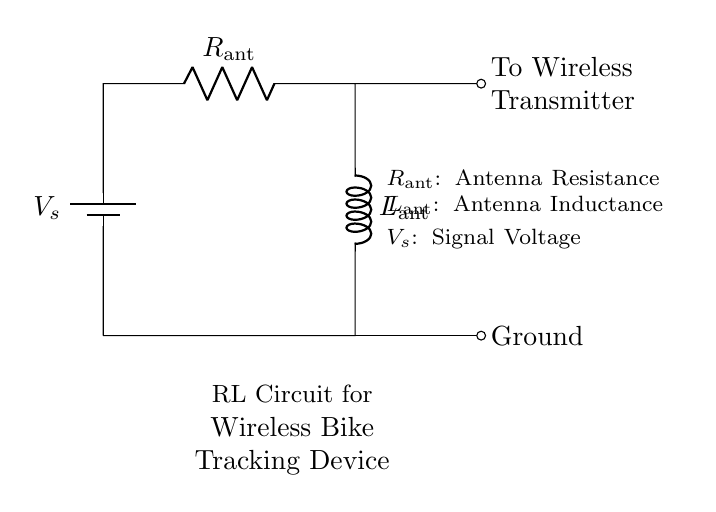What is the signal voltage in the circuit? The signal voltage is indicated by \( V_{s} \) in the battery symbol. It represents the source voltage for the circuit.
Answer: \( V_{s} \) What components are present in the circuit? The circuit consists of a battery, a resistor, and an inductor, which are labeled as \( V_{s} \), \( R_{\text{ant}} \), and \( L_{\text{ant}} \) respectively.
Answer: Battery, Resistor, Inductor What does \( R_{\text{ant}} \) represent? \( R_{\text{ant}} \) corresponds to the resistance of the antenna in the circuit, as indicated in the description.
Answer: Antenna Resistance How are the resistor and inductor connected in this circuit? The resistor and inductor are connected in series, as shown by the direct connection between them without any branching.
Answer: Series What is the function of the inductor in this circuit? The inductor serves to store energy in the magnetic field due to the current flowing through it, which is important for the functionality of wireless communication.
Answer: Energy Storage What happens to the overall impedance as frequency increases in an RL circuit? As frequency increases, the inductive reactance increases while resistance remains constant, resulting in higher overall impedance, affecting current flow.
Answer: Increases What is the significance of the wireless transmitter in this circuit? The wireless transmitter is connected to the circuit and plays a crucial role in sending signals wirelessly, leveraging the energy provided by the RL circuit.
Answer: Signal Transmission 